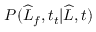<formula> <loc_0><loc_0><loc_500><loc_500>P ( \widehat { L } _ { f } , t _ { t } | \widehat { L } , t )</formula> 